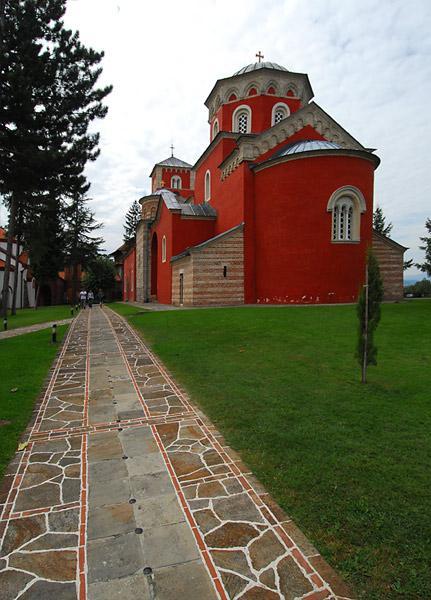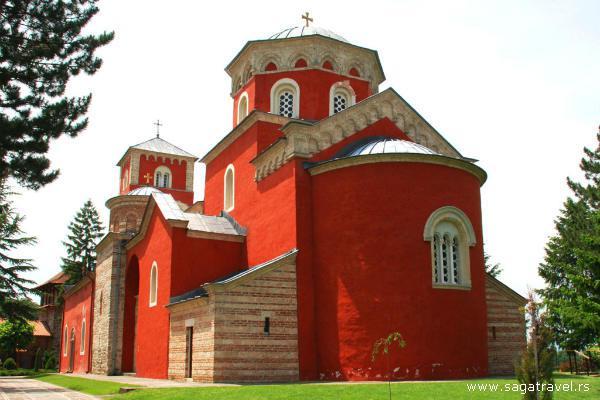The first image is the image on the left, the second image is the image on the right. Examine the images to the left and right. Is the description "One of the images shows a long narrow paved path leading to an orange building with a cross atop." accurate? Answer yes or no. Yes. The first image is the image on the left, the second image is the image on the right. Assess this claim about the two images: "Both images show a sprawling red-orange building with at least one cross-topped dome roof and multiple arch windows.". Correct or not? Answer yes or no. Yes. 